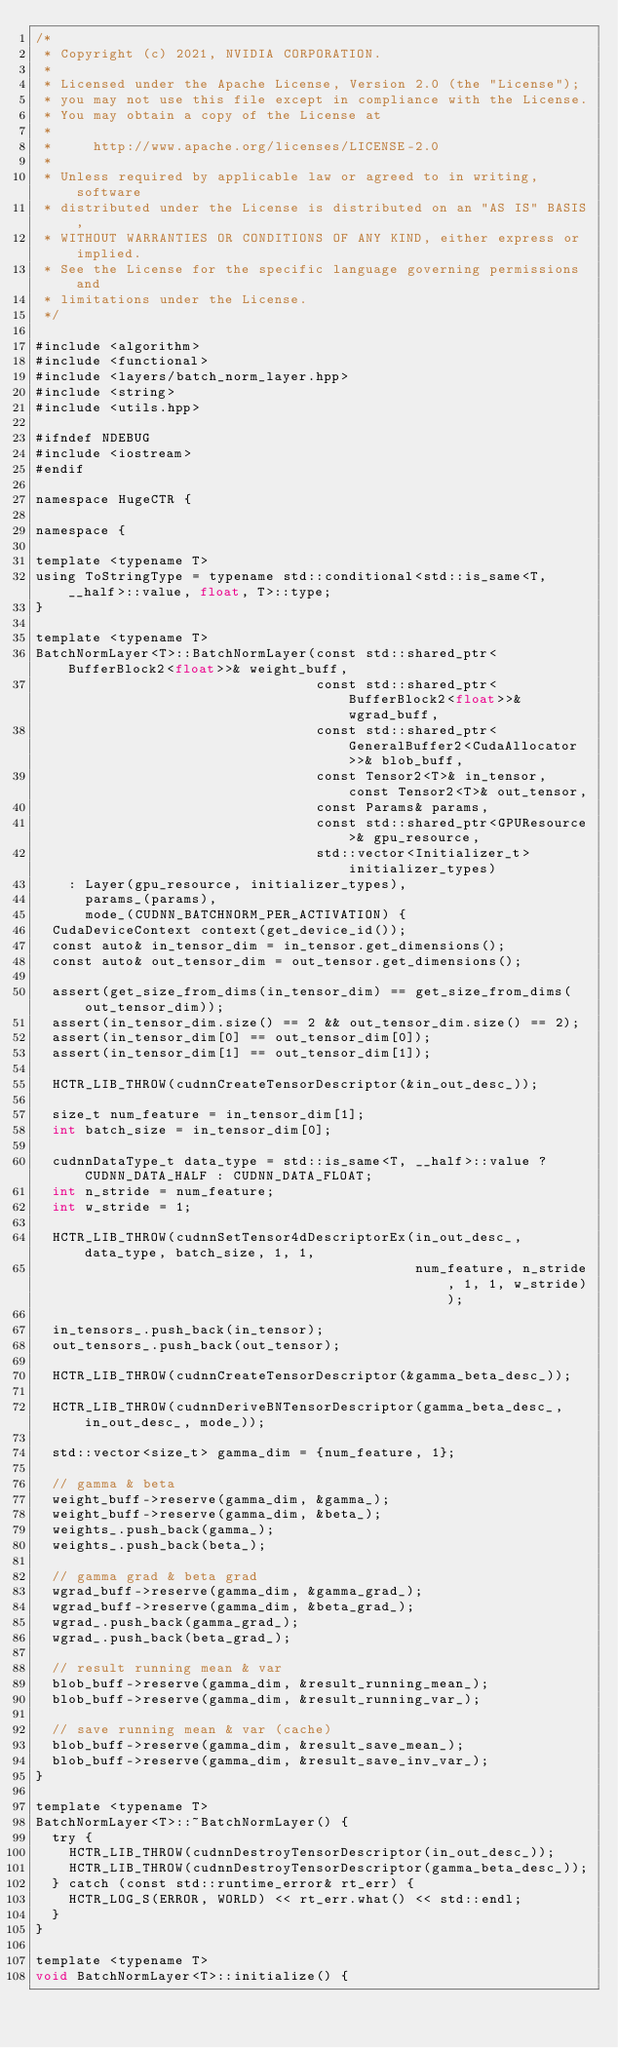Convert code to text. <code><loc_0><loc_0><loc_500><loc_500><_Cuda_>/*
 * Copyright (c) 2021, NVIDIA CORPORATION.
 *
 * Licensed under the Apache License, Version 2.0 (the "License");
 * you may not use this file except in compliance with the License.
 * You may obtain a copy of the License at
 *
 *     http://www.apache.org/licenses/LICENSE-2.0
 *
 * Unless required by applicable law or agreed to in writing, software
 * distributed under the License is distributed on an "AS IS" BASIS,
 * WITHOUT WARRANTIES OR CONDITIONS OF ANY KIND, either express or implied.
 * See the License for the specific language governing permissions and
 * limitations under the License.
 */

#include <algorithm>
#include <functional>
#include <layers/batch_norm_layer.hpp>
#include <string>
#include <utils.hpp>

#ifndef NDEBUG
#include <iostream>
#endif

namespace HugeCTR {

namespace {

template <typename T>
using ToStringType = typename std::conditional<std::is_same<T, __half>::value, float, T>::type;
}

template <typename T>
BatchNormLayer<T>::BatchNormLayer(const std::shared_ptr<BufferBlock2<float>>& weight_buff,
                                  const std::shared_ptr<BufferBlock2<float>>& wgrad_buff,
                                  const std::shared_ptr<GeneralBuffer2<CudaAllocator>>& blob_buff,
                                  const Tensor2<T>& in_tensor, const Tensor2<T>& out_tensor,
                                  const Params& params,
                                  const std::shared_ptr<GPUResource>& gpu_resource,
                                  std::vector<Initializer_t> initializer_types)
    : Layer(gpu_resource, initializer_types),
      params_(params),
      mode_(CUDNN_BATCHNORM_PER_ACTIVATION) {
  CudaDeviceContext context(get_device_id());
  const auto& in_tensor_dim = in_tensor.get_dimensions();
  const auto& out_tensor_dim = out_tensor.get_dimensions();

  assert(get_size_from_dims(in_tensor_dim) == get_size_from_dims(out_tensor_dim));
  assert(in_tensor_dim.size() == 2 && out_tensor_dim.size() == 2);
  assert(in_tensor_dim[0] == out_tensor_dim[0]);
  assert(in_tensor_dim[1] == out_tensor_dim[1]);

  HCTR_LIB_THROW(cudnnCreateTensorDescriptor(&in_out_desc_));

  size_t num_feature = in_tensor_dim[1];
  int batch_size = in_tensor_dim[0];

  cudnnDataType_t data_type = std::is_same<T, __half>::value ? CUDNN_DATA_HALF : CUDNN_DATA_FLOAT;
  int n_stride = num_feature;
  int w_stride = 1;

  HCTR_LIB_THROW(cudnnSetTensor4dDescriptorEx(in_out_desc_, data_type, batch_size, 1, 1,
                                              num_feature, n_stride, 1, 1, w_stride));

  in_tensors_.push_back(in_tensor);
  out_tensors_.push_back(out_tensor);

  HCTR_LIB_THROW(cudnnCreateTensorDescriptor(&gamma_beta_desc_));

  HCTR_LIB_THROW(cudnnDeriveBNTensorDescriptor(gamma_beta_desc_, in_out_desc_, mode_));

  std::vector<size_t> gamma_dim = {num_feature, 1};

  // gamma & beta
  weight_buff->reserve(gamma_dim, &gamma_);
  weight_buff->reserve(gamma_dim, &beta_);
  weights_.push_back(gamma_);
  weights_.push_back(beta_);

  // gamma grad & beta grad
  wgrad_buff->reserve(gamma_dim, &gamma_grad_);
  wgrad_buff->reserve(gamma_dim, &beta_grad_);
  wgrad_.push_back(gamma_grad_);
  wgrad_.push_back(beta_grad_);

  // result running mean & var
  blob_buff->reserve(gamma_dim, &result_running_mean_);
  blob_buff->reserve(gamma_dim, &result_running_var_);

  // save running mean & var (cache)
  blob_buff->reserve(gamma_dim, &result_save_mean_);
  blob_buff->reserve(gamma_dim, &result_save_inv_var_);
}

template <typename T>
BatchNormLayer<T>::~BatchNormLayer() {
  try {
    HCTR_LIB_THROW(cudnnDestroyTensorDescriptor(in_out_desc_));
    HCTR_LIB_THROW(cudnnDestroyTensorDescriptor(gamma_beta_desc_));
  } catch (const std::runtime_error& rt_err) {
    HCTR_LOG_S(ERROR, WORLD) << rt_err.what() << std::endl;
  }
}

template <typename T>
void BatchNormLayer<T>::initialize() {</code> 